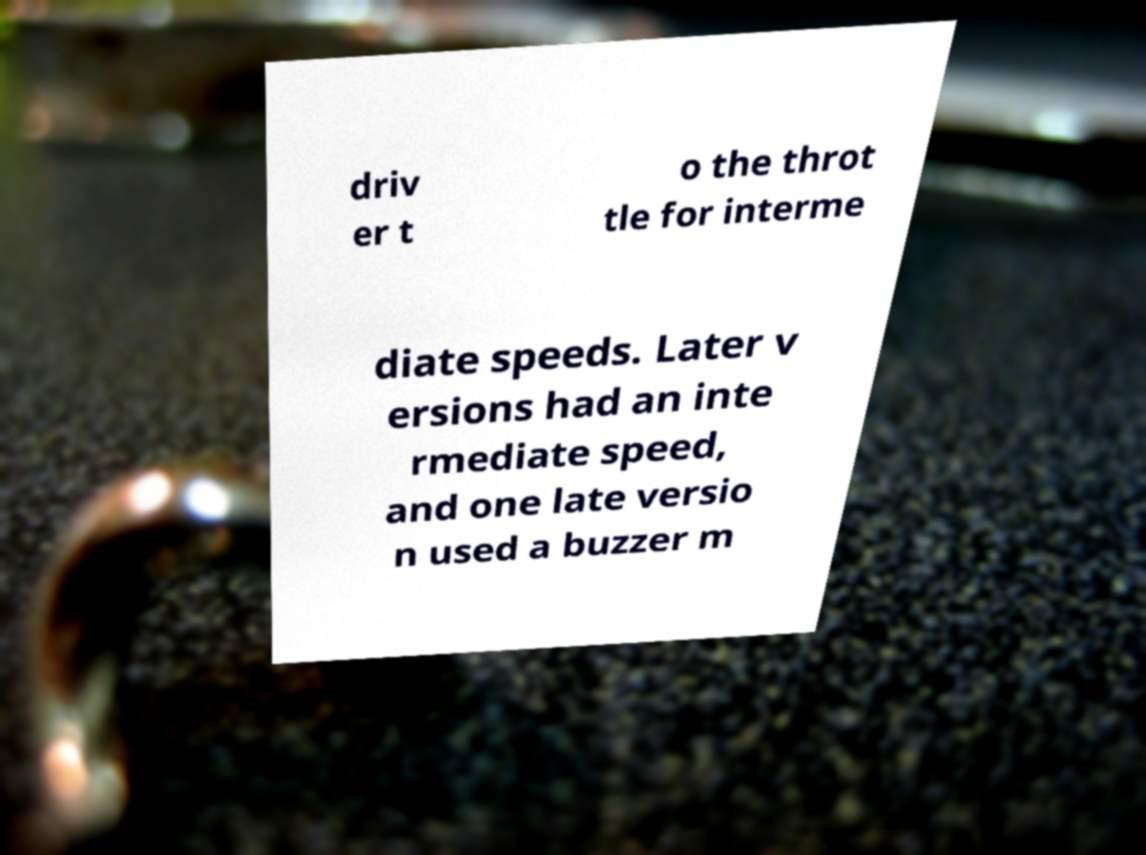Could you assist in decoding the text presented in this image and type it out clearly? driv er t o the throt tle for interme diate speeds. Later v ersions had an inte rmediate speed, and one late versio n used a buzzer m 